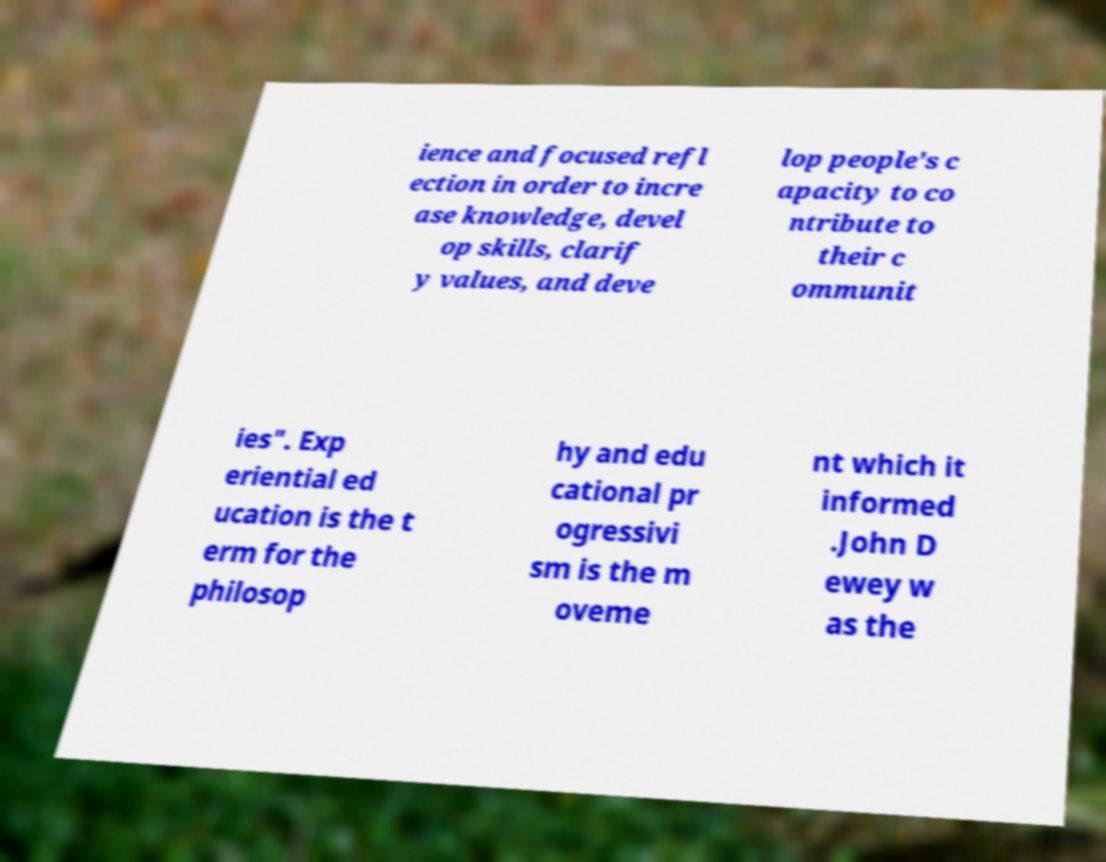Can you accurately transcribe the text from the provided image for me? ience and focused refl ection in order to incre ase knowledge, devel op skills, clarif y values, and deve lop people's c apacity to co ntribute to their c ommunit ies". Exp eriential ed ucation is the t erm for the philosop hy and edu cational pr ogressivi sm is the m oveme nt which it informed .John D ewey w as the 